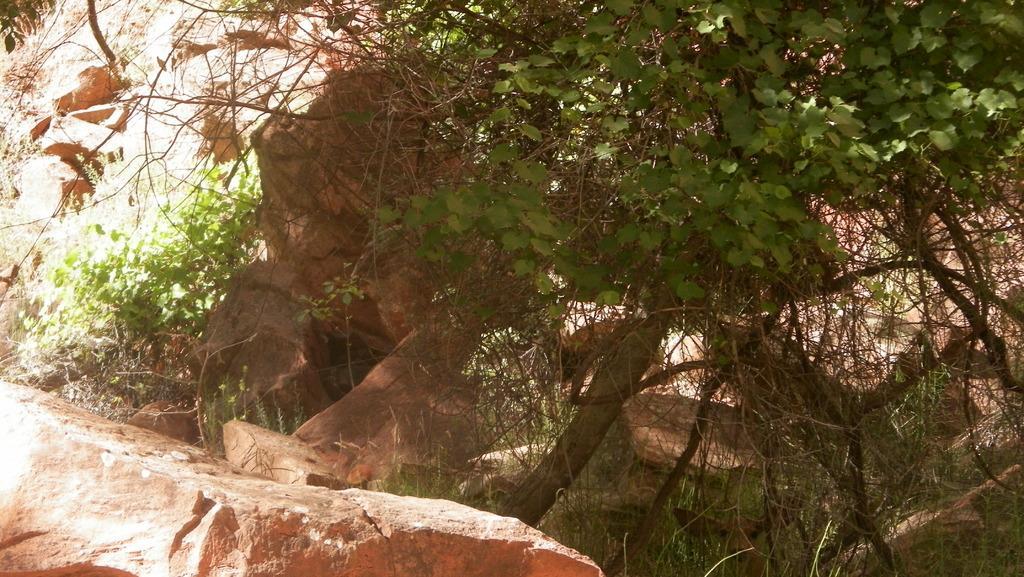Can you describe this image briefly? In this image we can see mountain and on mountain tree is there. 